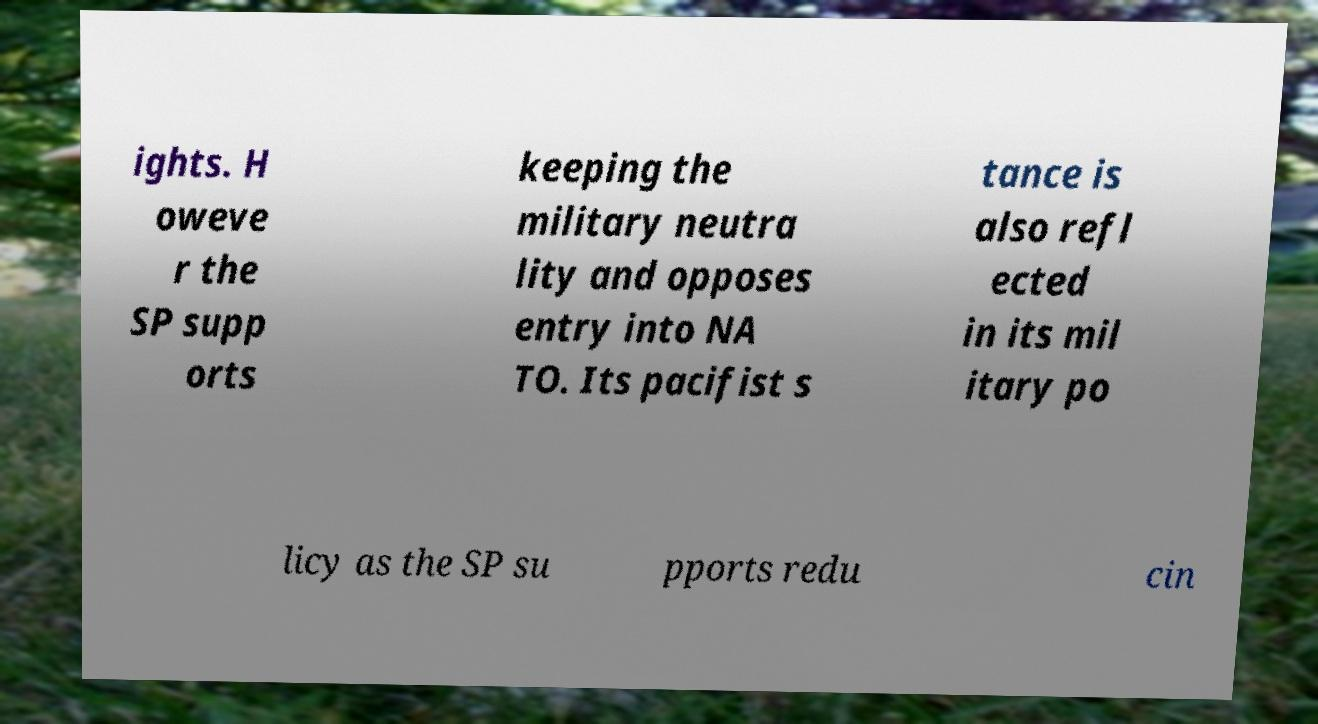I need the written content from this picture converted into text. Can you do that? ights. H oweve r the SP supp orts keeping the military neutra lity and opposes entry into NA TO. Its pacifist s tance is also refl ected in its mil itary po licy as the SP su pports redu cin 